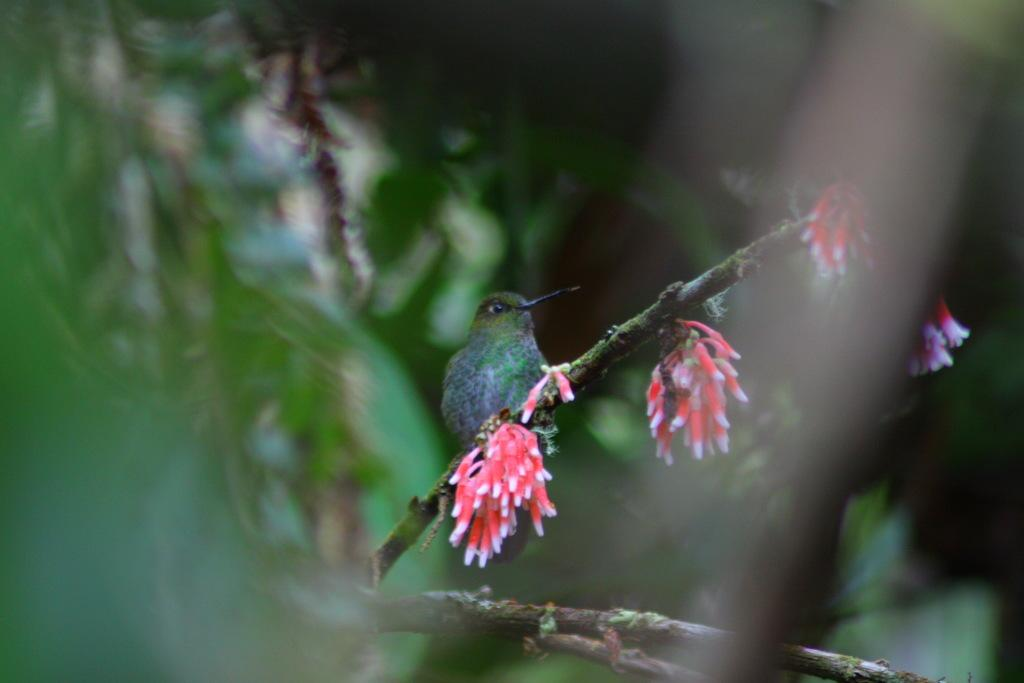What type of animal can be seen in the image? There is a bird in the image. Where is the bird located in the image? The bird is standing on the stem of a tree. What is the tree in the image characterized by? The tree has flowers. What type of fuel is the bird using to fly in the image? The bird is not flying in the image, and therefore it is not using any fuel. 